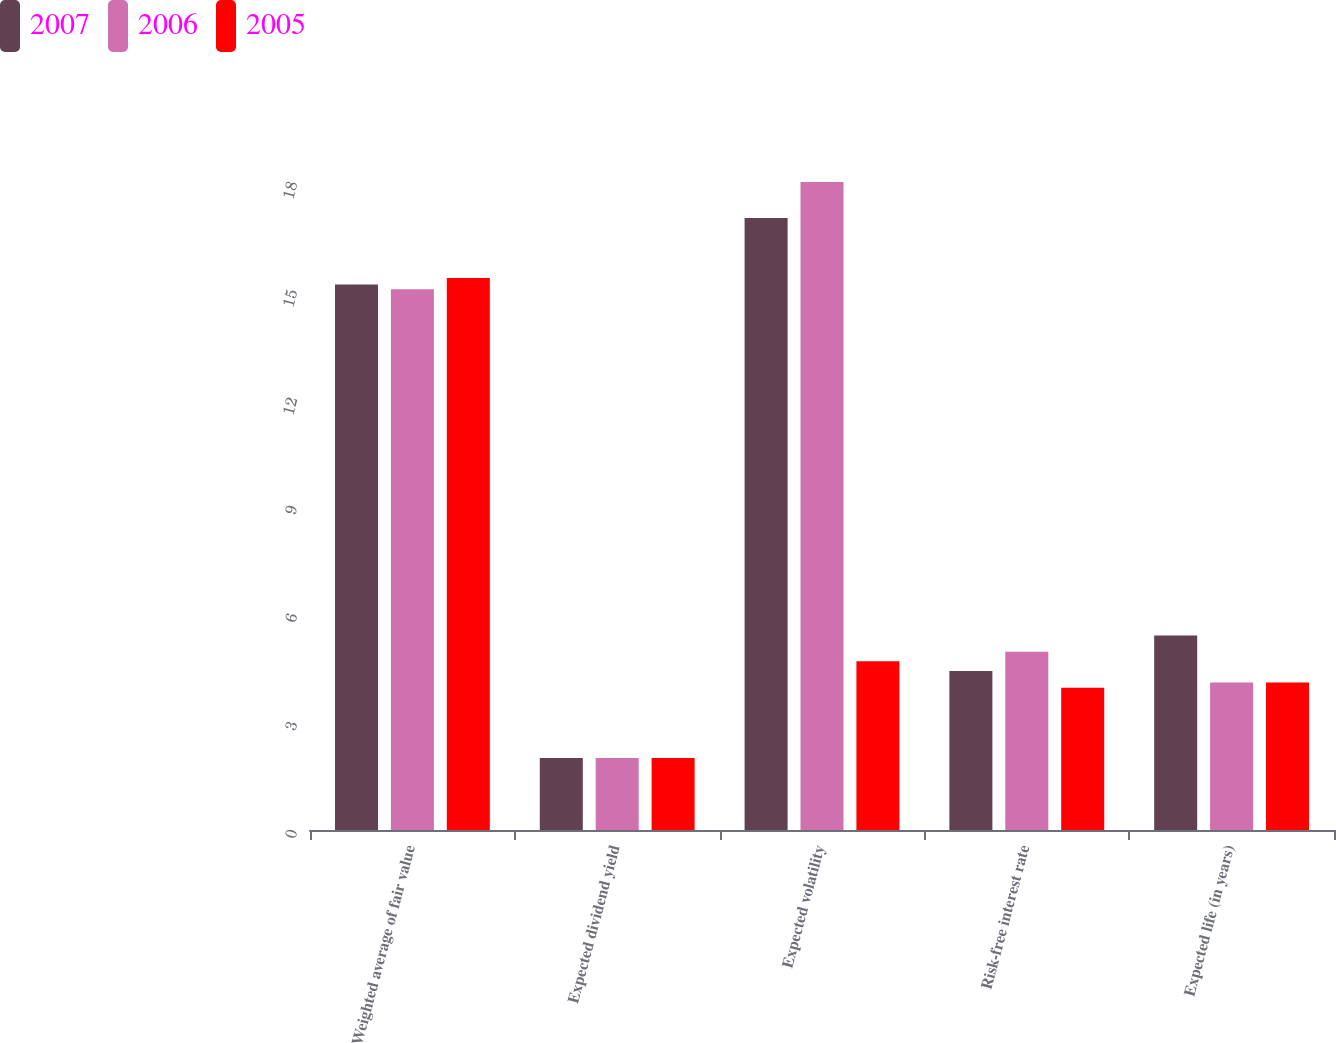<chart> <loc_0><loc_0><loc_500><loc_500><stacked_bar_chart><ecel><fcel>Weighted average of fair value<fcel>Expected dividend yield<fcel>Expected volatility<fcel>Risk-free interest rate<fcel>Expected life (in years)<nl><fcel>2007<fcel>15.15<fcel>2<fcel>17<fcel>4.42<fcel>5.4<nl><fcel>2006<fcel>15.02<fcel>2<fcel>18<fcel>4.95<fcel>4.1<nl><fcel>2005<fcel>15.33<fcel>2<fcel>4.685<fcel>3.95<fcel>4.1<nl></chart> 